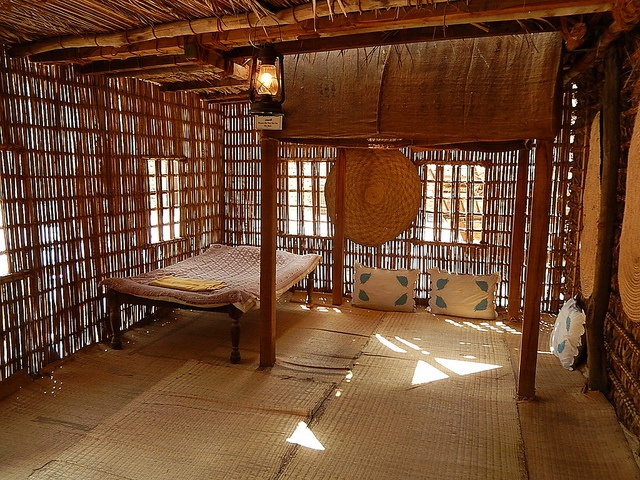Describe the objects in this image and their specific colors. I can see a bed in maroon, black, gray, and tan tones in this image. 